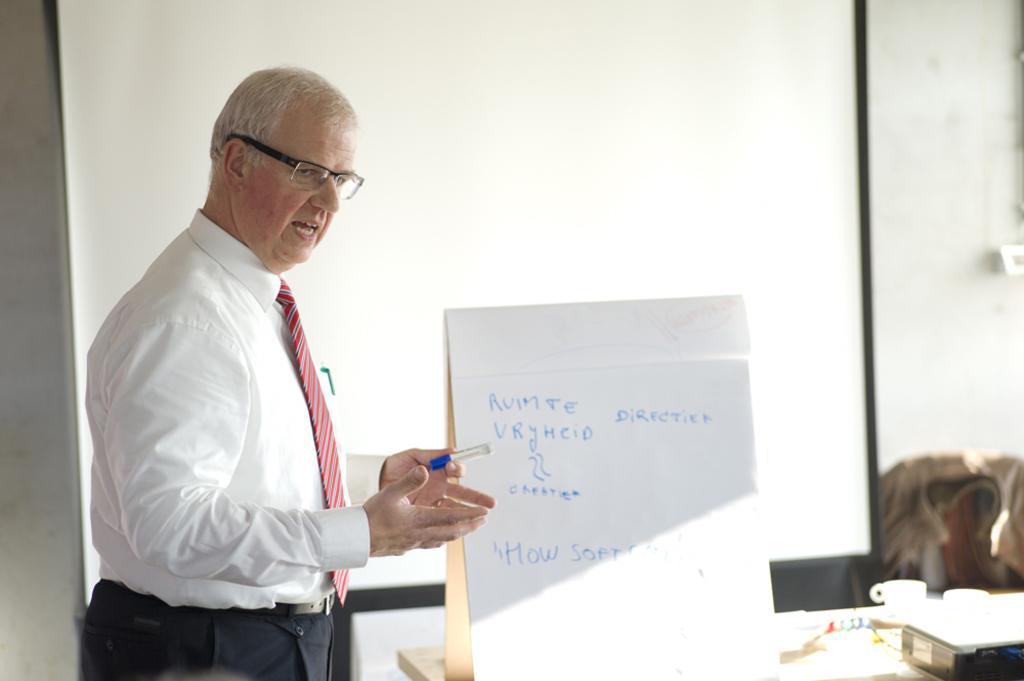In one or two sentences, can you explain what this image depicts? On the left side of the image we can see a man is standing and wearing shirt, pant, tie, spectacles and holding a marker and talking. In the bottom right corner we can see a table. On the table we can see a board, plates, cups, box. On the board we can see the text. In the background of the image we can see the wall, screen, circuit board, cloth. 